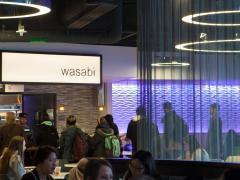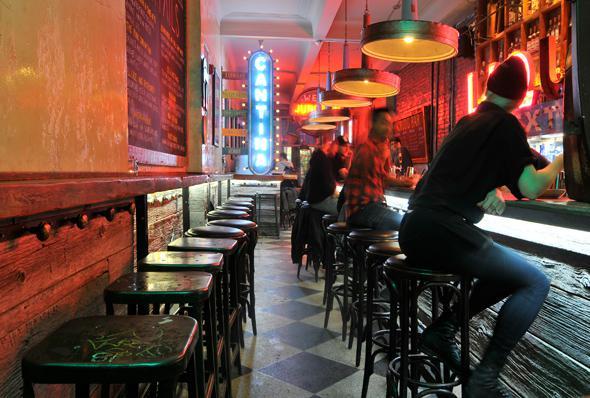The first image is the image on the left, the second image is the image on the right. Evaluate the accuracy of this statement regarding the images: "The right image shows a line of black benches with tufted backs in front of a low divider wall with a curtain behind it, and under lit hanging lights.". Is it true? Answer yes or no. No. The first image is the image on the left, the second image is the image on the right. For the images shown, is this caption "You can see barstools in one of the images." true? Answer yes or no. Yes. 